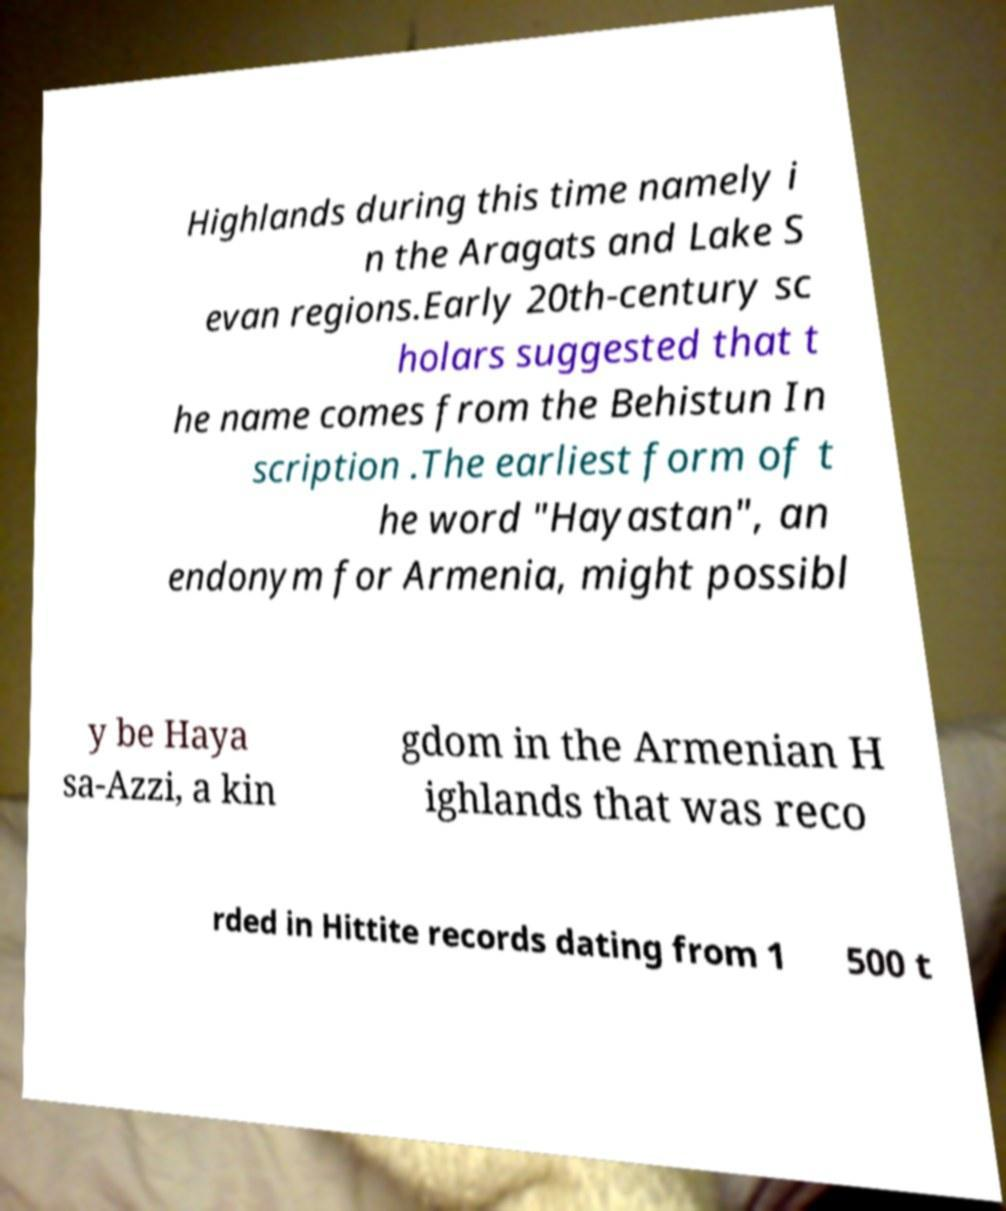Please read and relay the text visible in this image. What does it say? Highlands during this time namely i n the Aragats and Lake S evan regions.Early 20th-century sc holars suggested that t he name comes from the Behistun In scription .The earliest form of t he word "Hayastan", an endonym for Armenia, might possibl y be Haya sa-Azzi, a kin gdom in the Armenian H ighlands that was reco rded in Hittite records dating from 1 500 t 